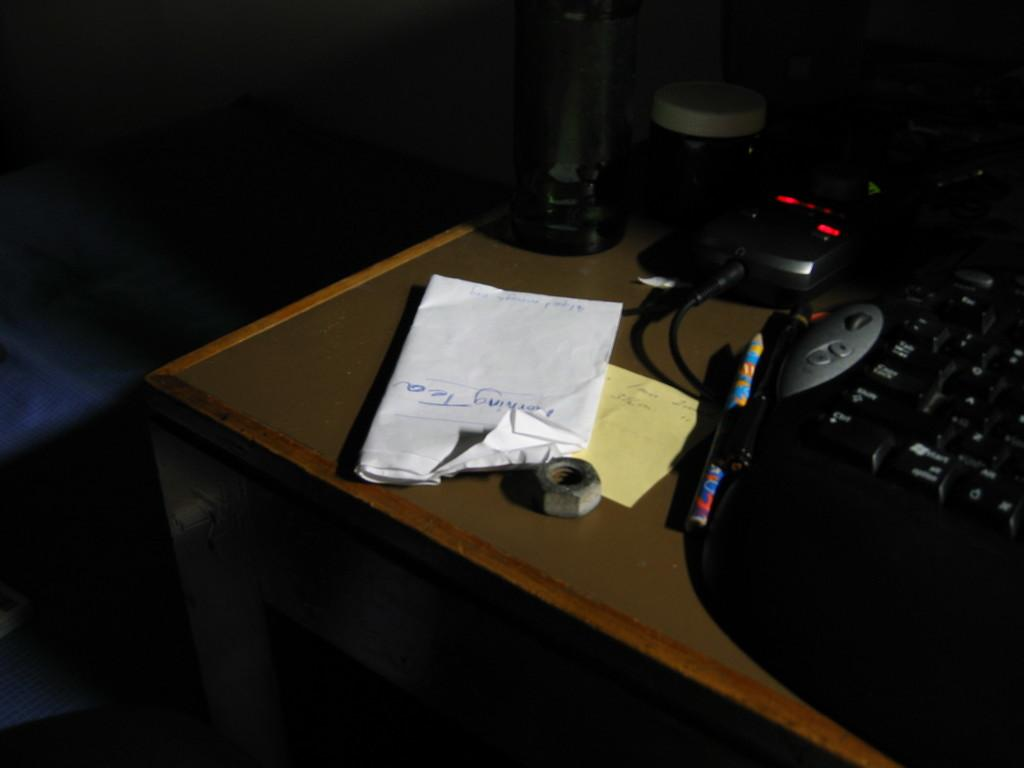<image>
Summarize the visual content of the image. A black key with many keys including a and z. 